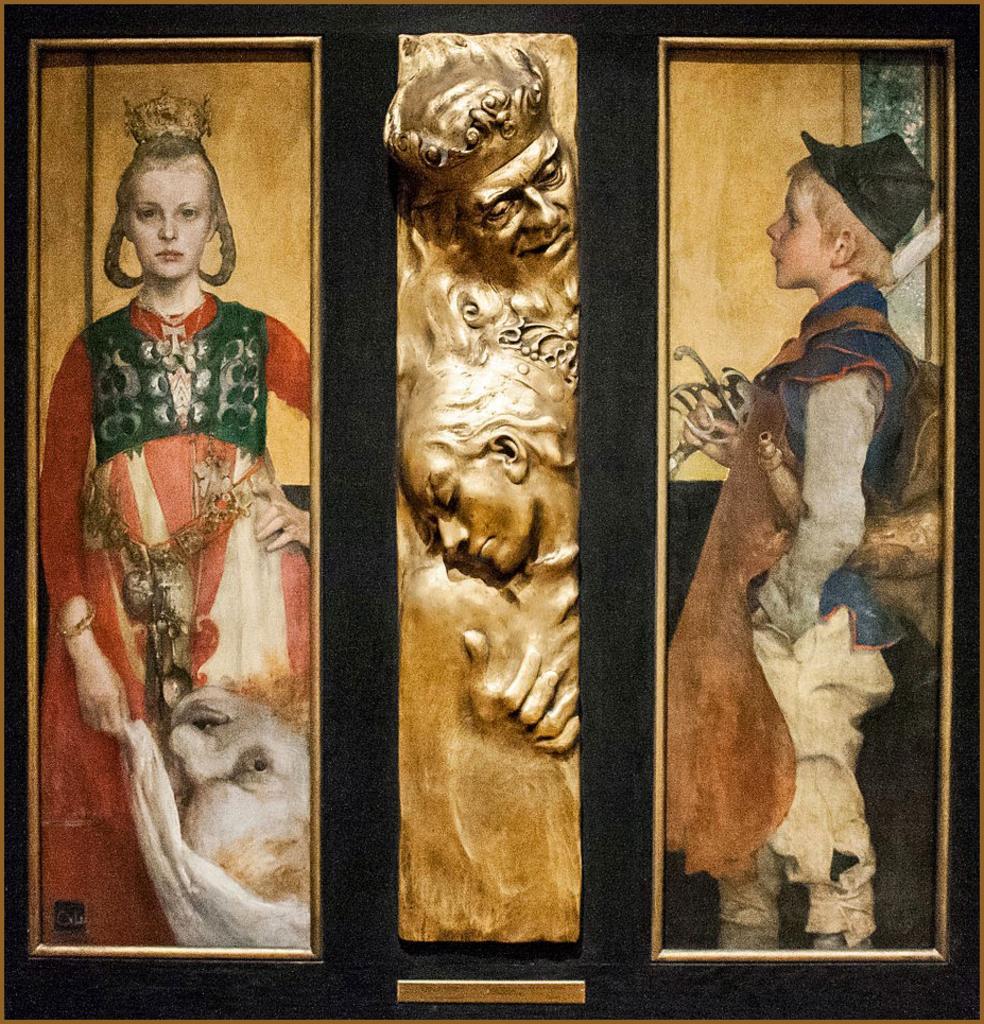How would you summarize this image in a sentence or two? In this image we can see two different frames and in this frame we can see a girl, in this frame we can see a boy and here we can see sculpture which is in gold color. 